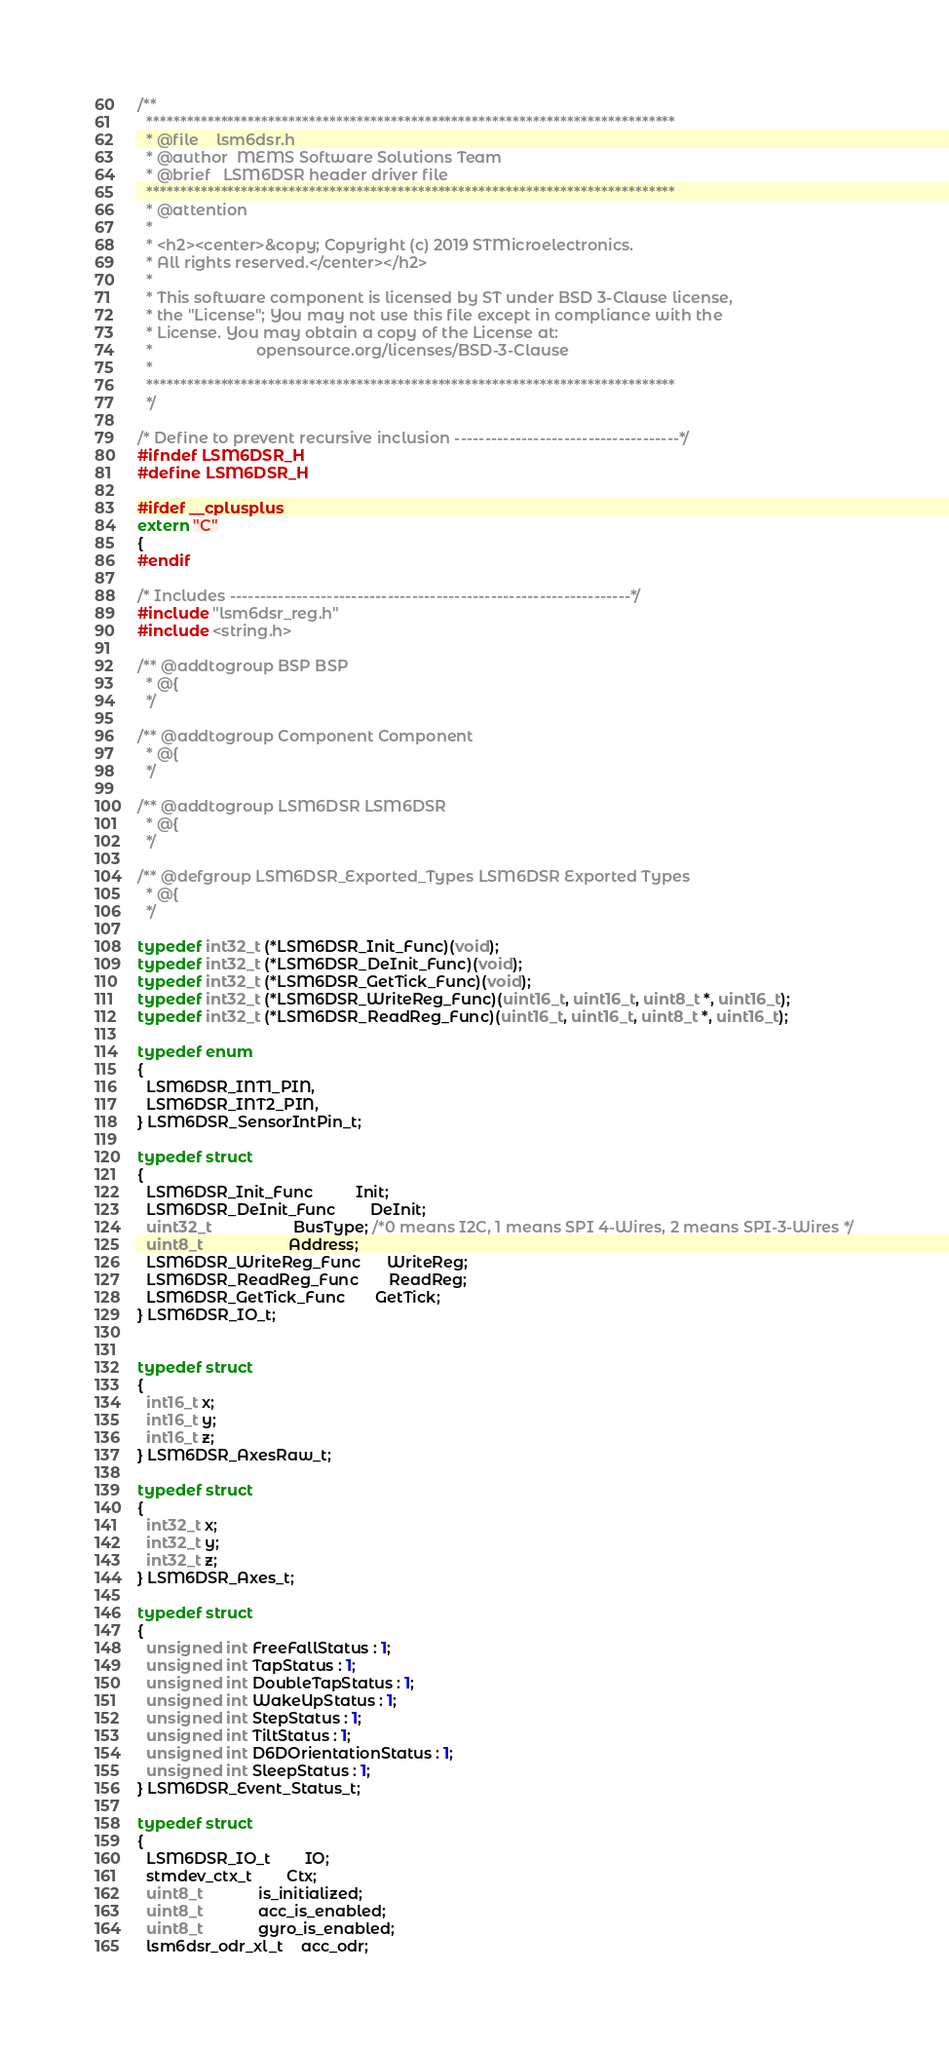<code> <loc_0><loc_0><loc_500><loc_500><_C_>/**
  ******************************************************************************
  * @file    lsm6dsr.h
  * @author  MEMS Software Solutions Team
  * @brief   LSM6DSR header driver file
  ******************************************************************************
  * @attention
  *
  * <h2><center>&copy; Copyright (c) 2019 STMicroelectronics.
  * All rights reserved.</center></h2>
  *
  * This software component is licensed by ST under BSD 3-Clause license,
  * the "License"; You may not use this file except in compliance with the
  * License. You may obtain a copy of the License at:
  *                        opensource.org/licenses/BSD-3-Clause
  *
  ******************************************************************************
  */

/* Define to prevent recursive inclusion -------------------------------------*/
#ifndef LSM6DSR_H
#define LSM6DSR_H

#ifdef __cplusplus
extern "C"
{
#endif

/* Includes ------------------------------------------------------------------*/
#include "lsm6dsr_reg.h"
#include <string.h>

/** @addtogroup BSP BSP
  * @{
  */

/** @addtogroup Component Component
  * @{
  */

/** @addtogroup LSM6DSR LSM6DSR
  * @{
  */

/** @defgroup LSM6DSR_Exported_Types LSM6DSR Exported Types
  * @{
  */

typedef int32_t (*LSM6DSR_Init_Func)(void);
typedef int32_t (*LSM6DSR_DeInit_Func)(void);
typedef int32_t (*LSM6DSR_GetTick_Func)(void);
typedef int32_t (*LSM6DSR_WriteReg_Func)(uint16_t, uint16_t, uint8_t *, uint16_t);
typedef int32_t (*LSM6DSR_ReadReg_Func)(uint16_t, uint16_t, uint8_t *, uint16_t);

typedef enum
{
  LSM6DSR_INT1_PIN,
  LSM6DSR_INT2_PIN,
} LSM6DSR_SensorIntPin_t;

typedef struct
{
  LSM6DSR_Init_Func          Init;
  LSM6DSR_DeInit_Func        DeInit;
  uint32_t                   BusType; /*0 means I2C, 1 means SPI 4-Wires, 2 means SPI-3-Wires */
  uint8_t                    Address;
  LSM6DSR_WriteReg_Func      WriteReg;
  LSM6DSR_ReadReg_Func       ReadReg;
  LSM6DSR_GetTick_Func       GetTick;
} LSM6DSR_IO_t;


typedef struct
{
  int16_t x;
  int16_t y;
  int16_t z;
} LSM6DSR_AxesRaw_t;

typedef struct
{
  int32_t x;
  int32_t y;
  int32_t z;
} LSM6DSR_Axes_t;

typedef struct
{
  unsigned int FreeFallStatus : 1;
  unsigned int TapStatus : 1;
  unsigned int DoubleTapStatus : 1;
  unsigned int WakeUpStatus : 1;
  unsigned int StepStatus : 1;
  unsigned int TiltStatus : 1;
  unsigned int D6DOrientationStatus : 1;
  unsigned int SleepStatus : 1;
} LSM6DSR_Event_Status_t;

typedef struct
{
  LSM6DSR_IO_t        IO;
  stmdev_ctx_t        Ctx;
  uint8_t             is_initialized;
  uint8_t             acc_is_enabled;
  uint8_t             gyro_is_enabled;
  lsm6dsr_odr_xl_t    acc_odr;</code> 